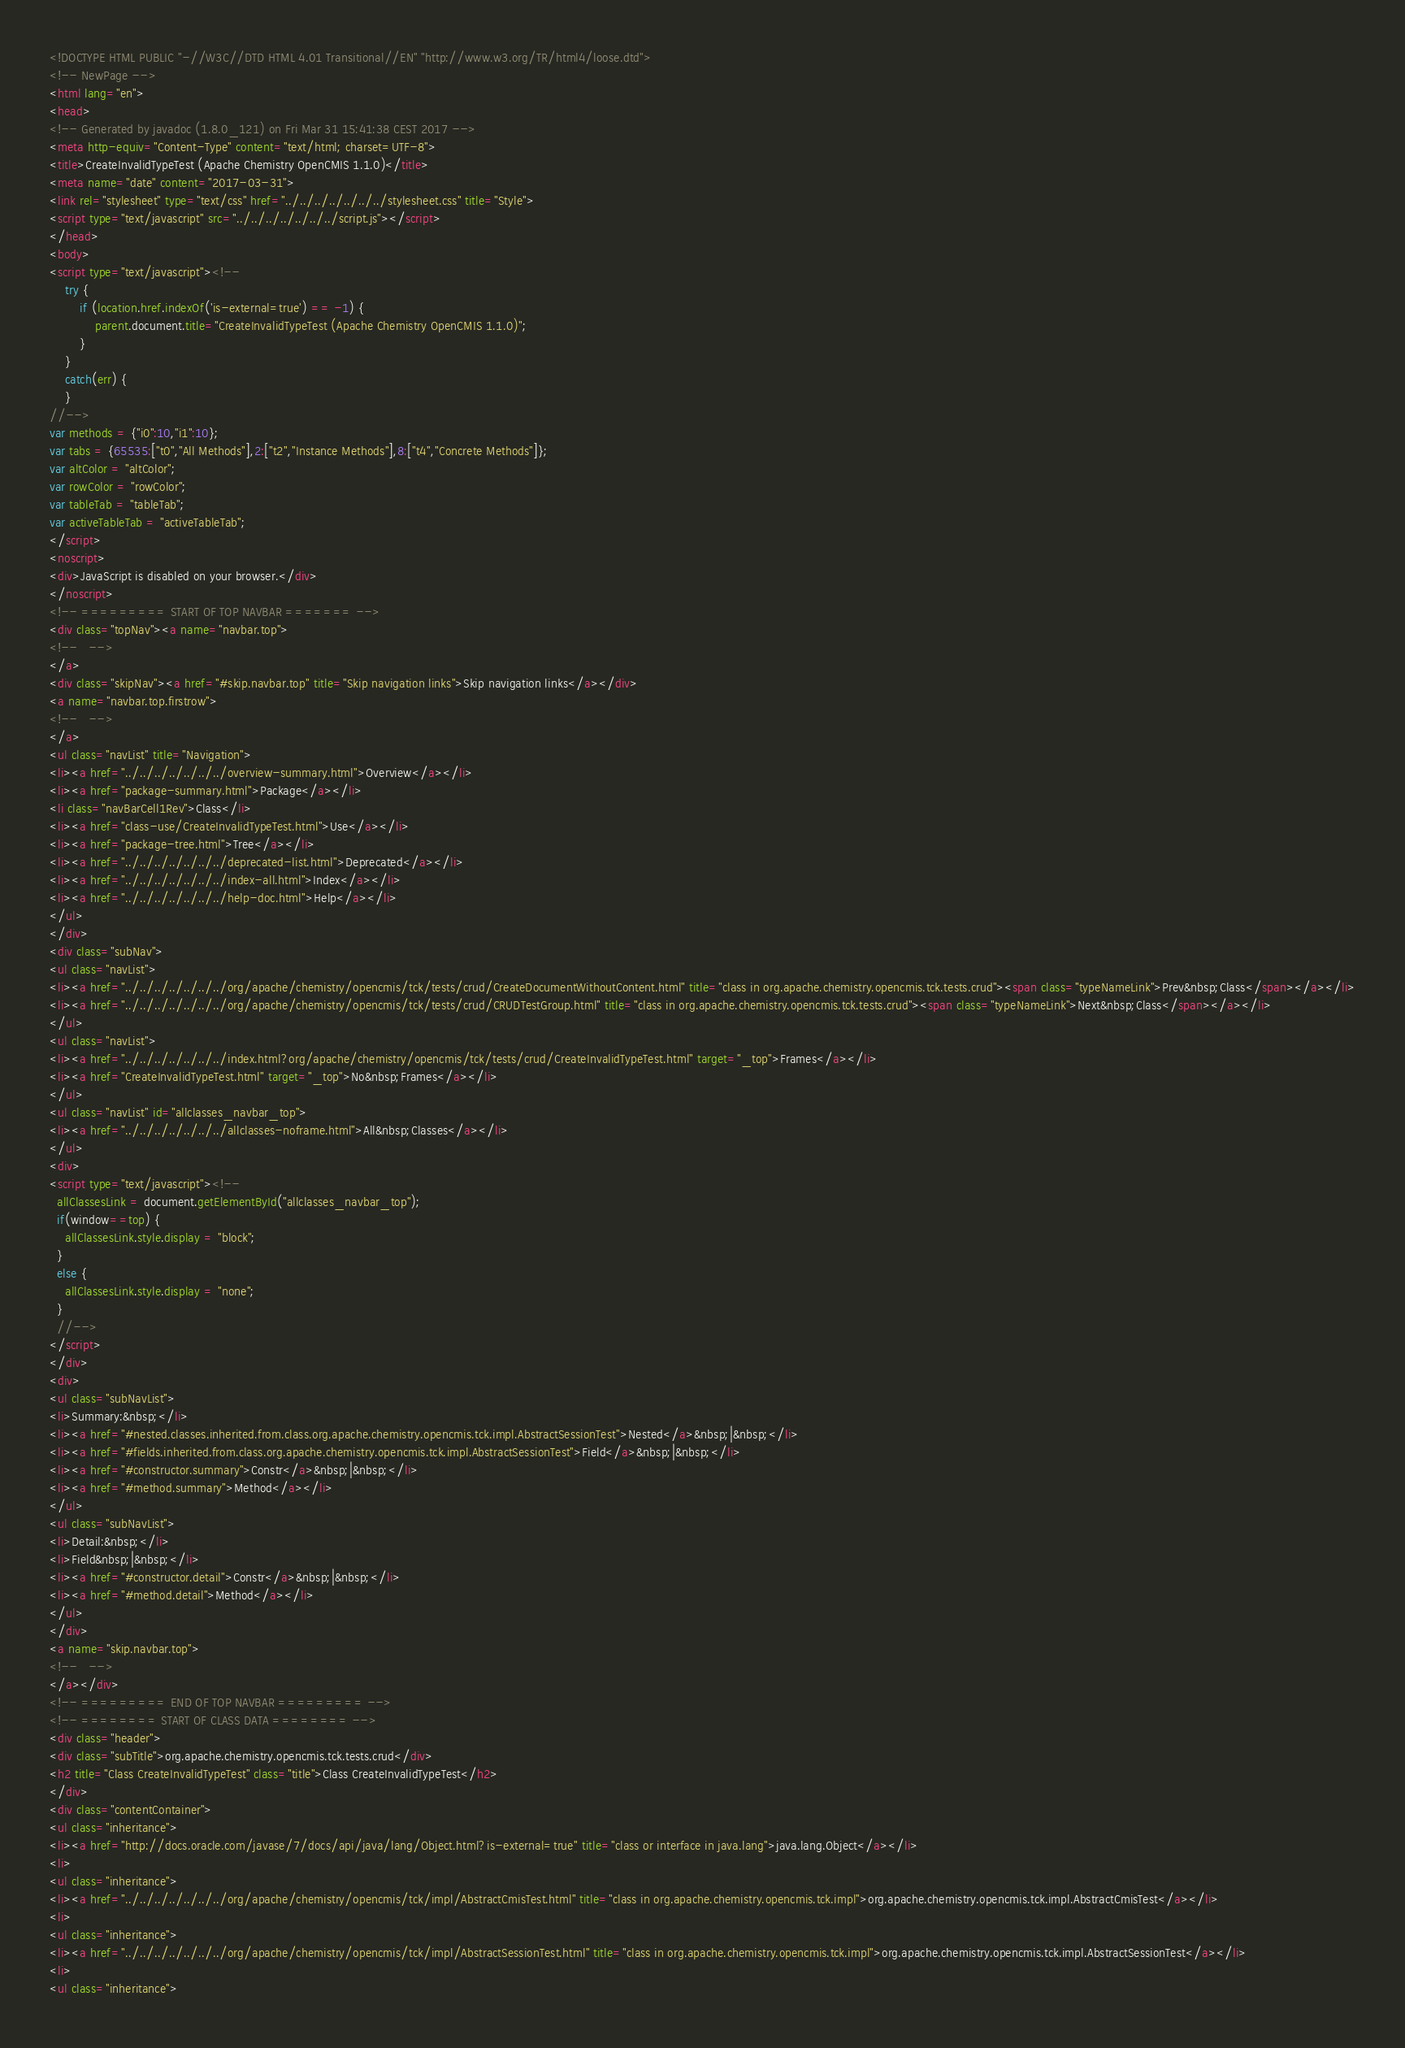<code> <loc_0><loc_0><loc_500><loc_500><_HTML_><!DOCTYPE HTML PUBLIC "-//W3C//DTD HTML 4.01 Transitional//EN" "http://www.w3.org/TR/html4/loose.dtd">
<!-- NewPage -->
<html lang="en">
<head>
<!-- Generated by javadoc (1.8.0_121) on Fri Mar 31 15:41:38 CEST 2017 -->
<meta http-equiv="Content-Type" content="text/html; charset=UTF-8">
<title>CreateInvalidTypeTest (Apache Chemistry OpenCMIS 1.1.0)</title>
<meta name="date" content="2017-03-31">
<link rel="stylesheet" type="text/css" href="../../../../../../../stylesheet.css" title="Style">
<script type="text/javascript" src="../../../../../../../script.js"></script>
</head>
<body>
<script type="text/javascript"><!--
    try {
        if (location.href.indexOf('is-external=true') == -1) {
            parent.document.title="CreateInvalidTypeTest (Apache Chemistry OpenCMIS 1.1.0)";
        }
    }
    catch(err) {
    }
//-->
var methods = {"i0":10,"i1":10};
var tabs = {65535:["t0","All Methods"],2:["t2","Instance Methods"],8:["t4","Concrete Methods"]};
var altColor = "altColor";
var rowColor = "rowColor";
var tableTab = "tableTab";
var activeTableTab = "activeTableTab";
</script>
<noscript>
<div>JavaScript is disabled on your browser.</div>
</noscript>
<!-- ========= START OF TOP NAVBAR ======= -->
<div class="topNav"><a name="navbar.top">
<!--   -->
</a>
<div class="skipNav"><a href="#skip.navbar.top" title="Skip navigation links">Skip navigation links</a></div>
<a name="navbar.top.firstrow">
<!--   -->
</a>
<ul class="navList" title="Navigation">
<li><a href="../../../../../../../overview-summary.html">Overview</a></li>
<li><a href="package-summary.html">Package</a></li>
<li class="navBarCell1Rev">Class</li>
<li><a href="class-use/CreateInvalidTypeTest.html">Use</a></li>
<li><a href="package-tree.html">Tree</a></li>
<li><a href="../../../../../../../deprecated-list.html">Deprecated</a></li>
<li><a href="../../../../../../../index-all.html">Index</a></li>
<li><a href="../../../../../../../help-doc.html">Help</a></li>
</ul>
</div>
<div class="subNav">
<ul class="navList">
<li><a href="../../../../../../../org/apache/chemistry/opencmis/tck/tests/crud/CreateDocumentWithoutContent.html" title="class in org.apache.chemistry.opencmis.tck.tests.crud"><span class="typeNameLink">Prev&nbsp;Class</span></a></li>
<li><a href="../../../../../../../org/apache/chemistry/opencmis/tck/tests/crud/CRUDTestGroup.html" title="class in org.apache.chemistry.opencmis.tck.tests.crud"><span class="typeNameLink">Next&nbsp;Class</span></a></li>
</ul>
<ul class="navList">
<li><a href="../../../../../../../index.html?org/apache/chemistry/opencmis/tck/tests/crud/CreateInvalidTypeTest.html" target="_top">Frames</a></li>
<li><a href="CreateInvalidTypeTest.html" target="_top">No&nbsp;Frames</a></li>
</ul>
<ul class="navList" id="allclasses_navbar_top">
<li><a href="../../../../../../../allclasses-noframe.html">All&nbsp;Classes</a></li>
</ul>
<div>
<script type="text/javascript"><!--
  allClassesLink = document.getElementById("allclasses_navbar_top");
  if(window==top) {
    allClassesLink.style.display = "block";
  }
  else {
    allClassesLink.style.display = "none";
  }
  //-->
</script>
</div>
<div>
<ul class="subNavList">
<li>Summary:&nbsp;</li>
<li><a href="#nested.classes.inherited.from.class.org.apache.chemistry.opencmis.tck.impl.AbstractSessionTest">Nested</a>&nbsp;|&nbsp;</li>
<li><a href="#fields.inherited.from.class.org.apache.chemistry.opencmis.tck.impl.AbstractSessionTest">Field</a>&nbsp;|&nbsp;</li>
<li><a href="#constructor.summary">Constr</a>&nbsp;|&nbsp;</li>
<li><a href="#method.summary">Method</a></li>
</ul>
<ul class="subNavList">
<li>Detail:&nbsp;</li>
<li>Field&nbsp;|&nbsp;</li>
<li><a href="#constructor.detail">Constr</a>&nbsp;|&nbsp;</li>
<li><a href="#method.detail">Method</a></li>
</ul>
</div>
<a name="skip.navbar.top">
<!--   -->
</a></div>
<!-- ========= END OF TOP NAVBAR ========= -->
<!-- ======== START OF CLASS DATA ======== -->
<div class="header">
<div class="subTitle">org.apache.chemistry.opencmis.tck.tests.crud</div>
<h2 title="Class CreateInvalidTypeTest" class="title">Class CreateInvalidTypeTest</h2>
</div>
<div class="contentContainer">
<ul class="inheritance">
<li><a href="http://docs.oracle.com/javase/7/docs/api/java/lang/Object.html?is-external=true" title="class or interface in java.lang">java.lang.Object</a></li>
<li>
<ul class="inheritance">
<li><a href="../../../../../../../org/apache/chemistry/opencmis/tck/impl/AbstractCmisTest.html" title="class in org.apache.chemistry.opencmis.tck.impl">org.apache.chemistry.opencmis.tck.impl.AbstractCmisTest</a></li>
<li>
<ul class="inheritance">
<li><a href="../../../../../../../org/apache/chemistry/opencmis/tck/impl/AbstractSessionTest.html" title="class in org.apache.chemistry.opencmis.tck.impl">org.apache.chemistry.opencmis.tck.impl.AbstractSessionTest</a></li>
<li>
<ul class="inheritance"></code> 